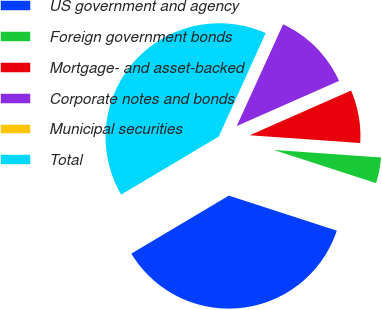<chart> <loc_0><loc_0><loc_500><loc_500><pie_chart><fcel>US government and agency<fcel>Foreign government bonds<fcel>Mortgage- and asset-backed<fcel>Corporate notes and bonds<fcel>Municipal securities<fcel>Total<nl><fcel>36.46%<fcel>3.88%<fcel>7.73%<fcel>11.58%<fcel>0.03%<fcel>40.31%<nl></chart> 